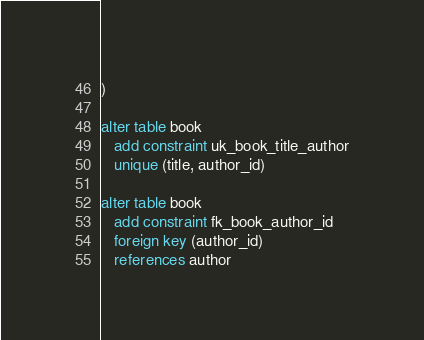<code> <loc_0><loc_0><loc_500><loc_500><_SQL_>)

alter table book
   add constraint uk_book_title_author
   unique (title, author_id)

alter table book
   add constraint fk_book_author_id
   foreign key (author_id)
   references author</code> 